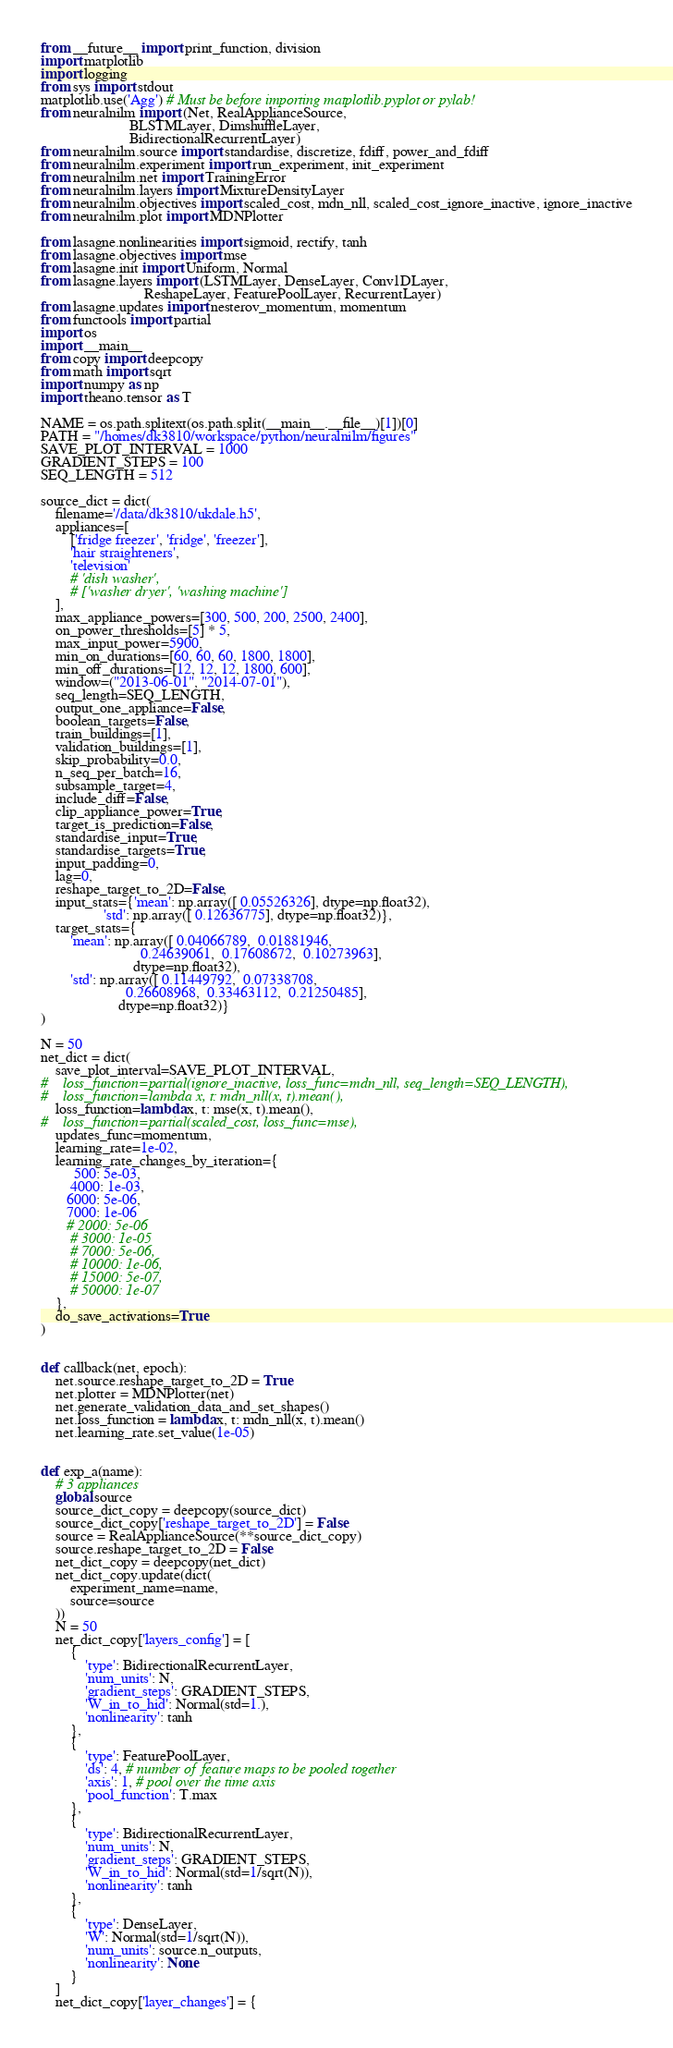Convert code to text. <code><loc_0><loc_0><loc_500><loc_500><_Python_>from __future__ import print_function, division
import matplotlib
import logging
from sys import stdout
matplotlib.use('Agg') # Must be before importing matplotlib.pyplot or pylab!
from neuralnilm import (Net, RealApplianceSource, 
                        BLSTMLayer, DimshuffleLayer, 
                        BidirectionalRecurrentLayer)
from neuralnilm.source import standardise, discretize, fdiff, power_and_fdiff
from neuralnilm.experiment import run_experiment, init_experiment
from neuralnilm.net import TrainingError
from neuralnilm.layers import MixtureDensityLayer
from neuralnilm.objectives import scaled_cost, mdn_nll, scaled_cost_ignore_inactive, ignore_inactive
from neuralnilm.plot import MDNPlotter

from lasagne.nonlinearities import sigmoid, rectify, tanh
from lasagne.objectives import mse
from lasagne.init import Uniform, Normal
from lasagne.layers import (LSTMLayer, DenseLayer, Conv1DLayer, 
                            ReshapeLayer, FeaturePoolLayer, RecurrentLayer)
from lasagne.updates import nesterov_momentum, momentum
from functools import partial
import os
import __main__
from copy import deepcopy
from math import sqrt
import numpy as np
import theano.tensor as T

NAME = os.path.splitext(os.path.split(__main__.__file__)[1])[0]
PATH = "/homes/dk3810/workspace/python/neuralnilm/figures"
SAVE_PLOT_INTERVAL = 1000
GRADIENT_STEPS = 100
SEQ_LENGTH = 512

source_dict = dict(
    filename='/data/dk3810/ukdale.h5',
    appliances=[
        ['fridge freezer', 'fridge', 'freezer'], 
        'hair straighteners', 
        'television'
        # 'dish washer',
        # ['washer dryer', 'washing machine']
    ],
    max_appliance_powers=[300, 500, 200, 2500, 2400],
    on_power_thresholds=[5] * 5,
    max_input_power=5900,
    min_on_durations=[60, 60, 60, 1800, 1800],
    min_off_durations=[12, 12, 12, 1800, 600],
    window=("2013-06-01", "2014-07-01"),
    seq_length=SEQ_LENGTH,
    output_one_appliance=False,
    boolean_targets=False,
    train_buildings=[1],
    validation_buildings=[1], 
    skip_probability=0.0,
    n_seq_per_batch=16,
    subsample_target=4,
    include_diff=False,
    clip_appliance_power=True,
    target_is_prediction=False,
    standardise_input=True,
    standardise_targets=True,
    input_padding=0,
    lag=0,
    reshape_target_to_2D=False,
    input_stats={'mean': np.array([ 0.05526326], dtype=np.float32),
                 'std': np.array([ 0.12636775], dtype=np.float32)},
    target_stats={
        'mean': np.array([ 0.04066789,  0.01881946,  
                           0.24639061,  0.17608672,  0.10273963], 
                         dtype=np.float32),
        'std': np.array([ 0.11449792,  0.07338708,  
                       0.26608968,  0.33463112,  0.21250485], 
                     dtype=np.float32)}
)

N = 50
net_dict = dict(        
    save_plot_interval=SAVE_PLOT_INTERVAL,
#    loss_function=partial(ignore_inactive, loss_func=mdn_nll, seq_length=SEQ_LENGTH),
#    loss_function=lambda x, t: mdn_nll(x, t).mean(),
    loss_function=lambda x, t: mse(x, t).mean(),
#    loss_function=partial(scaled_cost, loss_func=mse),
    updates_func=momentum,
    learning_rate=1e-02,
    learning_rate_changes_by_iteration={
         500: 5e-03,
        4000: 1e-03,
       6000: 5e-06,
       7000: 1e-06
       # 2000: 5e-06
        # 3000: 1e-05
        # 7000: 5e-06,
        # 10000: 1e-06,
        # 15000: 5e-07,
        # 50000: 1e-07
    },  
    do_save_activations=True
)


def callback(net, epoch):
    net.source.reshape_target_to_2D = True
    net.plotter = MDNPlotter(net)
    net.generate_validation_data_and_set_shapes()
    net.loss_function = lambda x, t: mdn_nll(x, t).mean()
    net.learning_rate.set_value(1e-05)


def exp_a(name):
    # 3 appliances
    global source
    source_dict_copy = deepcopy(source_dict)
    source_dict_copy['reshape_target_to_2D'] = False
    source = RealApplianceSource(**source_dict_copy)
    source.reshape_target_to_2D = False
    net_dict_copy = deepcopy(net_dict)
    net_dict_copy.update(dict(
        experiment_name=name,
        source=source
    ))
    N = 50
    net_dict_copy['layers_config'] = [
        {
            'type': BidirectionalRecurrentLayer,
            'num_units': N,
            'gradient_steps': GRADIENT_STEPS,
            'W_in_to_hid': Normal(std=1.),
            'nonlinearity': tanh
        },
        {
            'type': FeaturePoolLayer,
            'ds': 4, # number of feature maps to be pooled together
            'axis': 1, # pool over the time axis
            'pool_function': T.max
        },
        {
            'type': BidirectionalRecurrentLayer,
            'num_units': N,
            'gradient_steps': GRADIENT_STEPS,
            'W_in_to_hid': Normal(std=1/sqrt(N)),
            'nonlinearity': tanh
        },
        {
            'type': DenseLayer,
            'W': Normal(std=1/sqrt(N)),
            'num_units': source.n_outputs,
            'nonlinearity': None
        }
    ]
    net_dict_copy['layer_changes'] = {</code> 